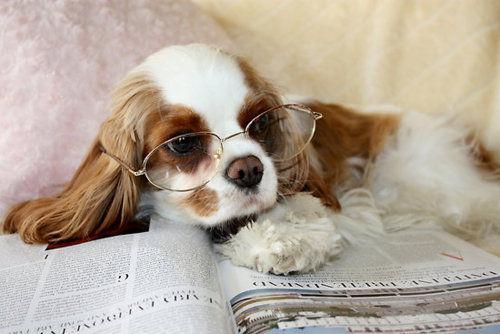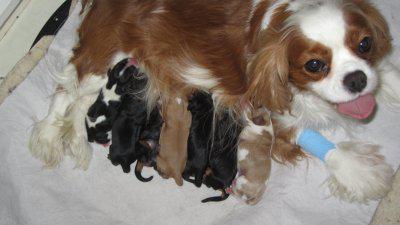The first image is the image on the left, the second image is the image on the right. Analyze the images presented: Is the assertion "There are two dogs with black ears and two dogs with brown ears sitting in a row in the image on the left." valid? Answer yes or no. No. 